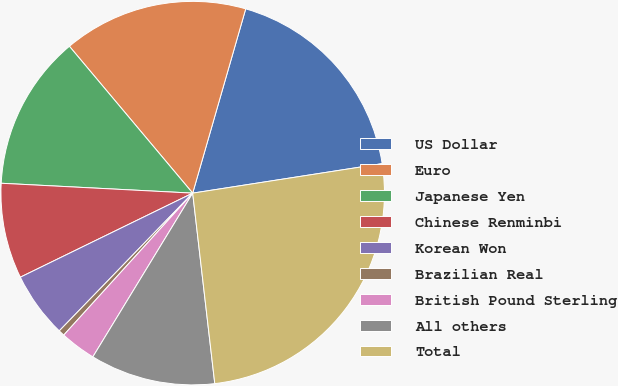Convert chart. <chart><loc_0><loc_0><loc_500><loc_500><pie_chart><fcel>US Dollar<fcel>Euro<fcel>Japanese Yen<fcel>Chinese Renminbi<fcel>Korean Won<fcel>Brazilian Real<fcel>British Pound Sterling<fcel>All others<fcel>Total<nl><fcel>18.08%<fcel>15.57%<fcel>13.06%<fcel>8.04%<fcel>5.53%<fcel>0.51%<fcel>3.02%<fcel>10.55%<fcel>25.61%<nl></chart> 